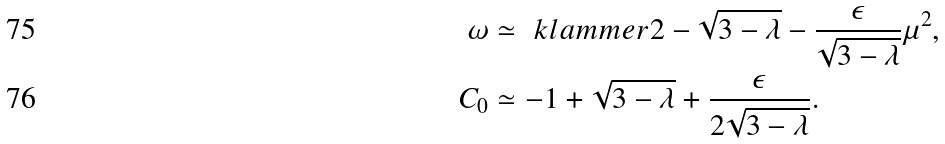Convert formula to latex. <formula><loc_0><loc_0><loc_500><loc_500>\omega & \simeq \ k l a m m e r { 2 - \sqrt { 3 - \lambda } - \frac { \epsilon } { \sqrt { 3 - \lambda } } } \mu ^ { 2 } , \\ C _ { 0 } & \simeq - 1 + \sqrt { 3 - \lambda } + \frac { \epsilon } { 2 \sqrt { 3 - \lambda } } .</formula> 